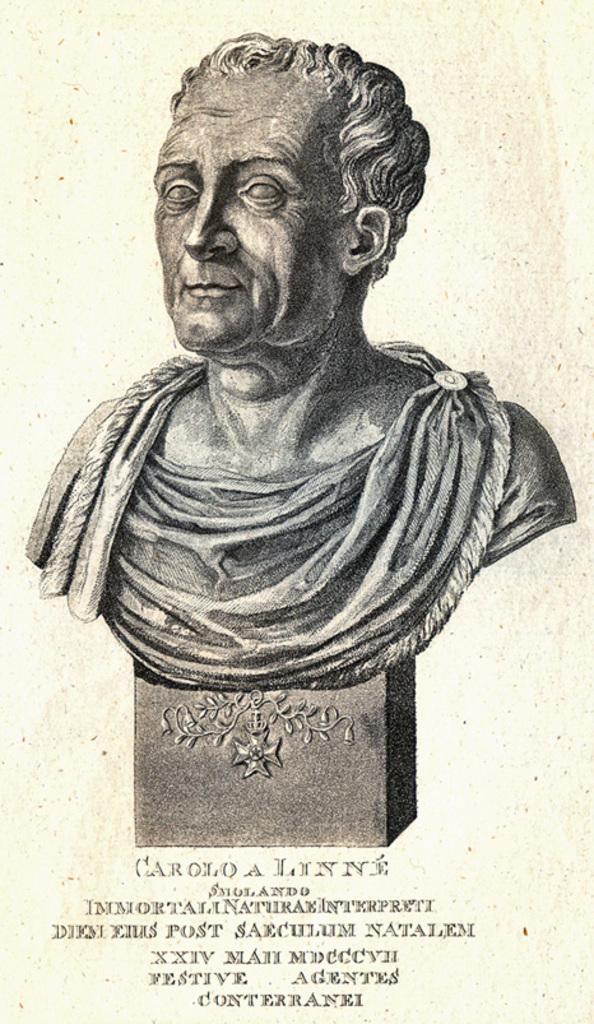Could you give a brief overview of what you see in this image? In this image I can see a picture of a statue of a person and I can see the cream colored background. 